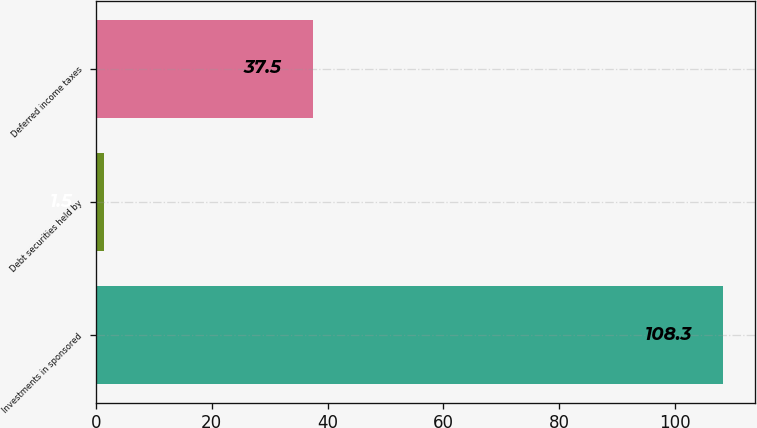<chart> <loc_0><loc_0><loc_500><loc_500><bar_chart><fcel>Investments in sponsored<fcel>Debt securities held by<fcel>Deferred income taxes<nl><fcel>108.3<fcel>1.5<fcel>37.5<nl></chart> 